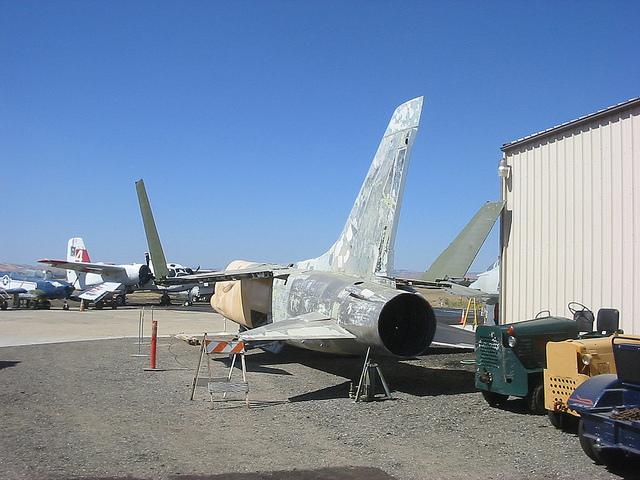Is there another plane in the photo?
Short answer required. Yes. Is it about to rain?
Answer briefly. No. Is this an Army or Air Force plane?
Keep it brief. Army. Can this jet fly?
Short answer required. No. What color is the broken jet?
Give a very brief answer. Gray. 